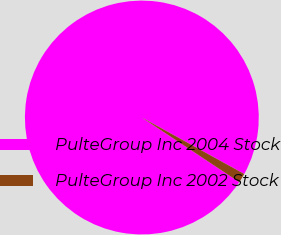Convert chart to OTSL. <chart><loc_0><loc_0><loc_500><loc_500><pie_chart><fcel>PulteGroup Inc 2004 Stock<fcel>PulteGroup Inc 2002 Stock<nl><fcel>98.7%<fcel>1.3%<nl></chart> 